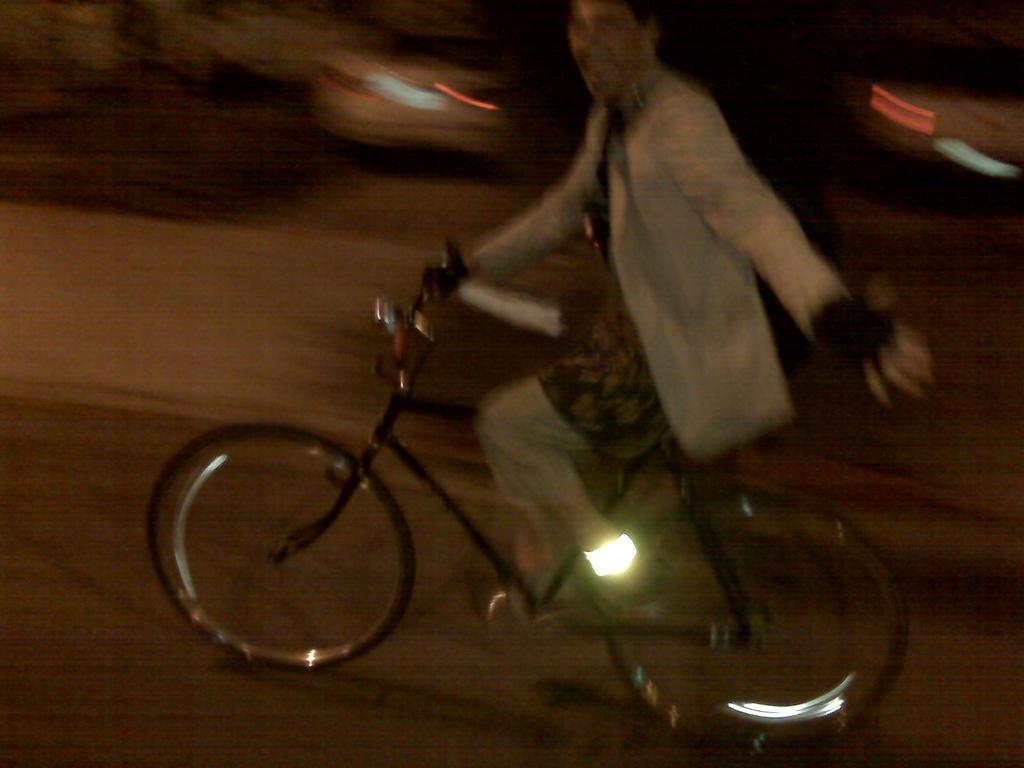How would you summarize this image in a sentence or two? In this picture there is a person riding bicycle on the road. At the back there are vehicles and the image is blurry. 